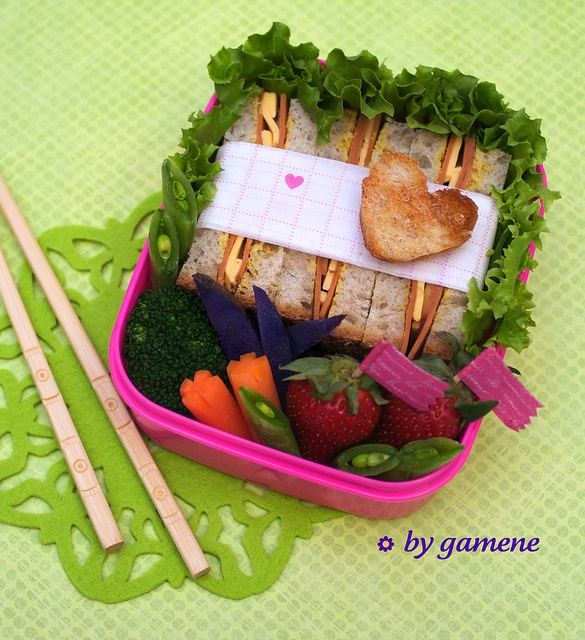Describe the objects in this image and their specific colors. I can see sandwich in lightgreen, lavender, darkgray, and tan tones, bowl in khaki, magenta, and brown tones, broccoli in lightgreen, black, darkgreen, and maroon tones, sandwich in khaki, tan, and gray tones, and sandwich in lightgreen, brown, tan, maroon, and olive tones in this image. 